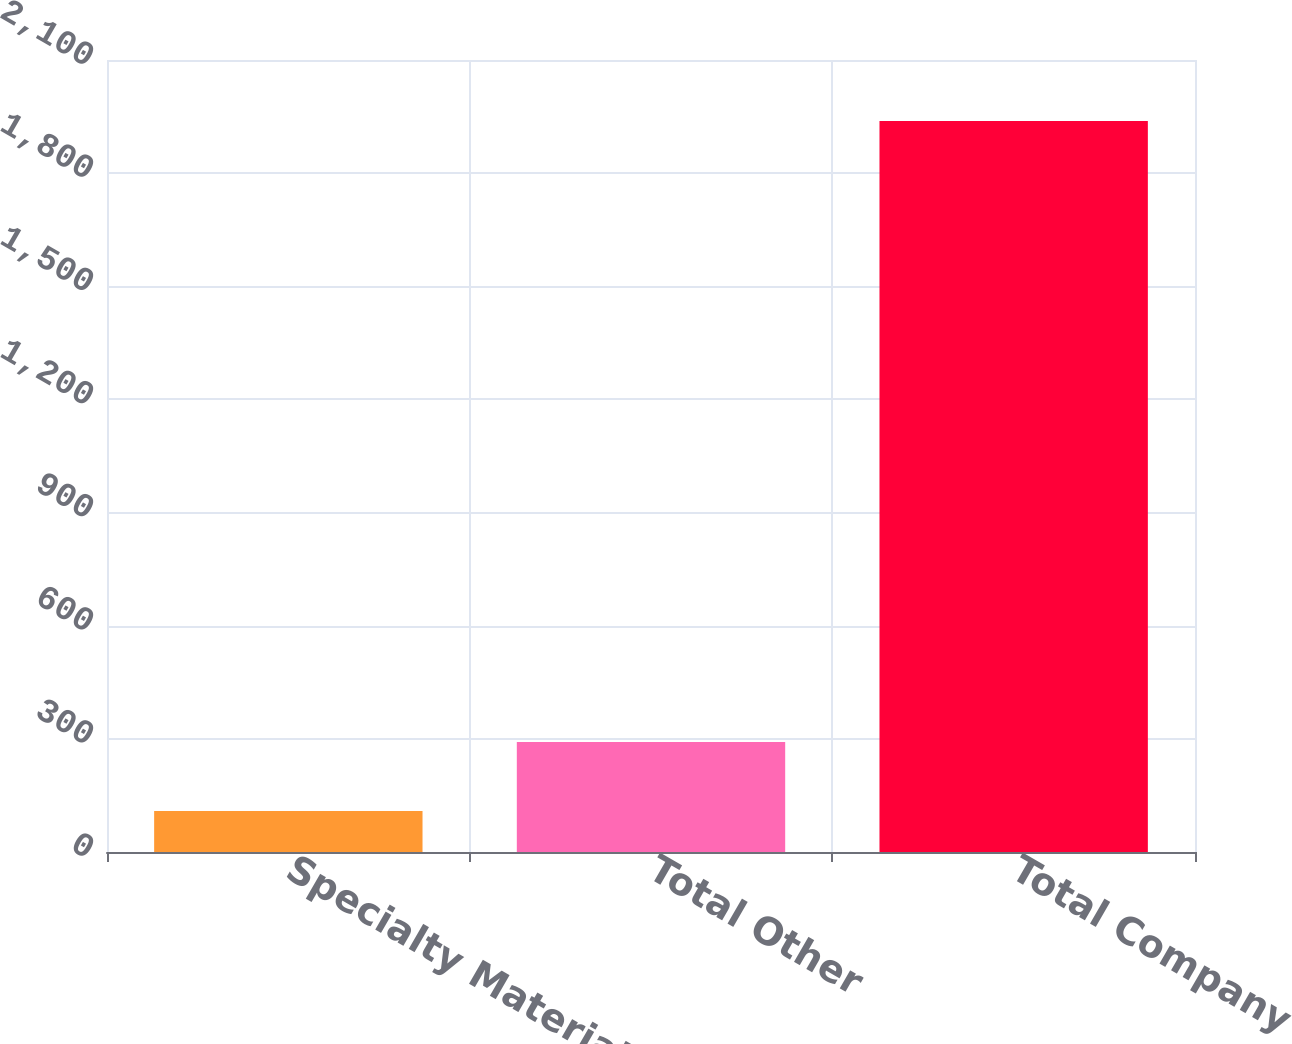Convert chart. <chart><loc_0><loc_0><loc_500><loc_500><bar_chart><fcel>Specialty Materials<fcel>Total Other<fcel>Total Company<nl><fcel>109<fcel>291.91<fcel>1938.1<nl></chart> 